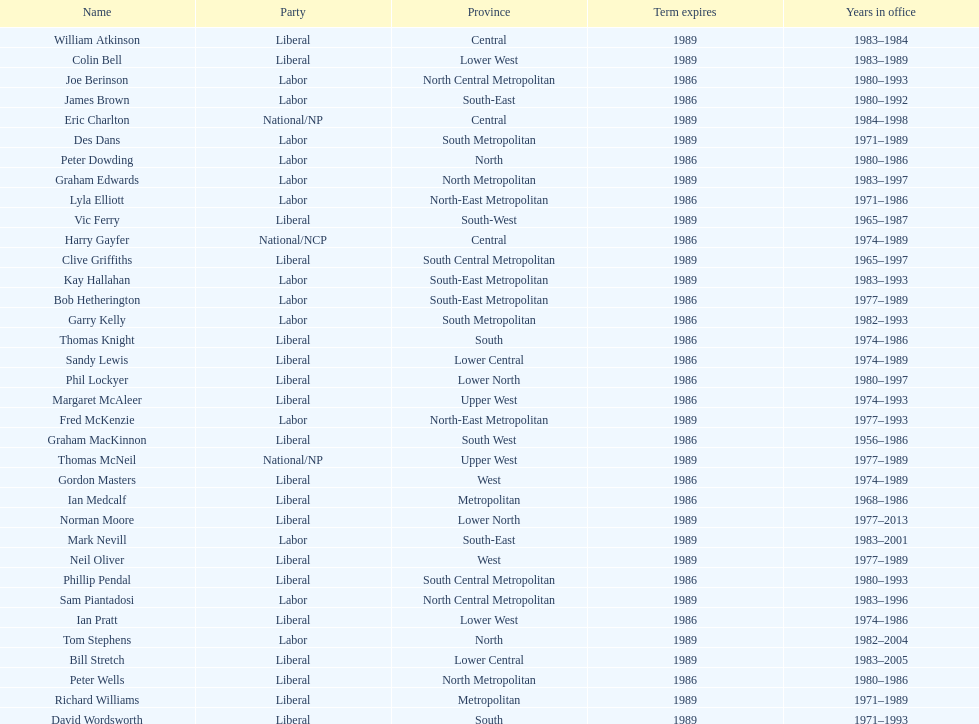Who is the final person mentioned with a last name starting with "p"? Ian Pratt. 